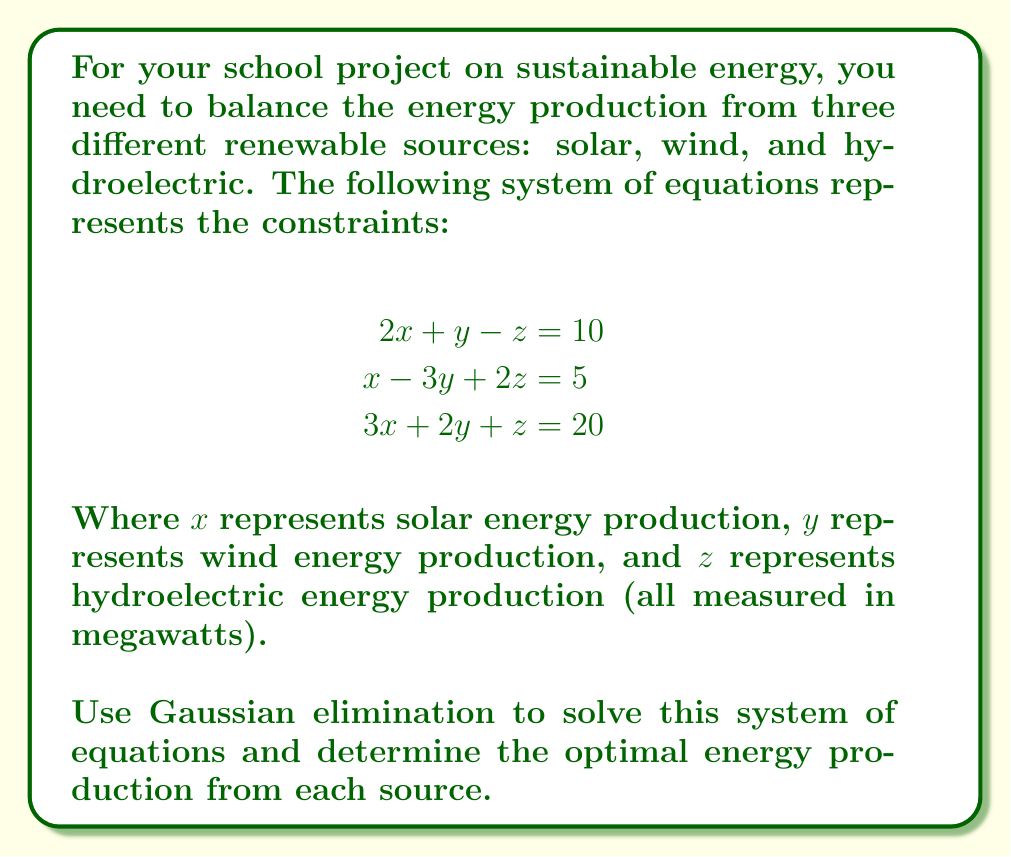Teach me how to tackle this problem. Let's solve this system using Gaussian elimination:

1) First, we write the augmented matrix:

   $$\begin{bmatrix}
   2 & 1 & -1 & 10 \\
   1 & -3 & 2 & 5 \\
   3 & 2 & 1 & 20
   \end{bmatrix}$$

2) We'll use the first row as our pivot. Subtract 1/2 of the first row from the second row:

   $$\begin{bmatrix}
   2 & 1 & -1 & 10 \\
   0 & -3.5 & 2.5 & 0 \\
   3 & 2 & 1 & 20
   \end{bmatrix}$$

3) Now subtract 3/2 of the first row from the third row:

   $$\begin{bmatrix}
   2 & 1 & -1 & 10 \\
   0 & -3.5 & 2.5 & 0 \\
   0 & 0.5 & 2.5 & 5
   \end{bmatrix}$$

4) Use the second row as the new pivot. Add 1/7 of the second row to the third row:

   $$\begin{bmatrix}
   2 & 1 & -1 & 10 \\
   0 & -3.5 & 2.5 & 0 \\
   0 & 0 & 2.857 & 5
   \end{bmatrix}$$

5) Now we have an upper triangular matrix. We can solve for $z$ from the last row:

   $2.857z = 5$
   $z = 1.75$

6) Substitute this value into the second row to solve for $y$:

   $-3.5y + 2.5(1.75) = 0$
   $-3.5y = -4.375$
   $y = 1.25$

7) Finally, substitute these values into the first row to solve for $x$:

   $2x + 1.25 - 1.75 = 10$
   $2x = 10.5$
   $x = 5.25$

Therefore, the solution is $x = 5.25$, $y = 1.25$, and $z = 1.75$.
Answer: $x = 5.25$, $y = 1.25$, $z = 1.75$ 